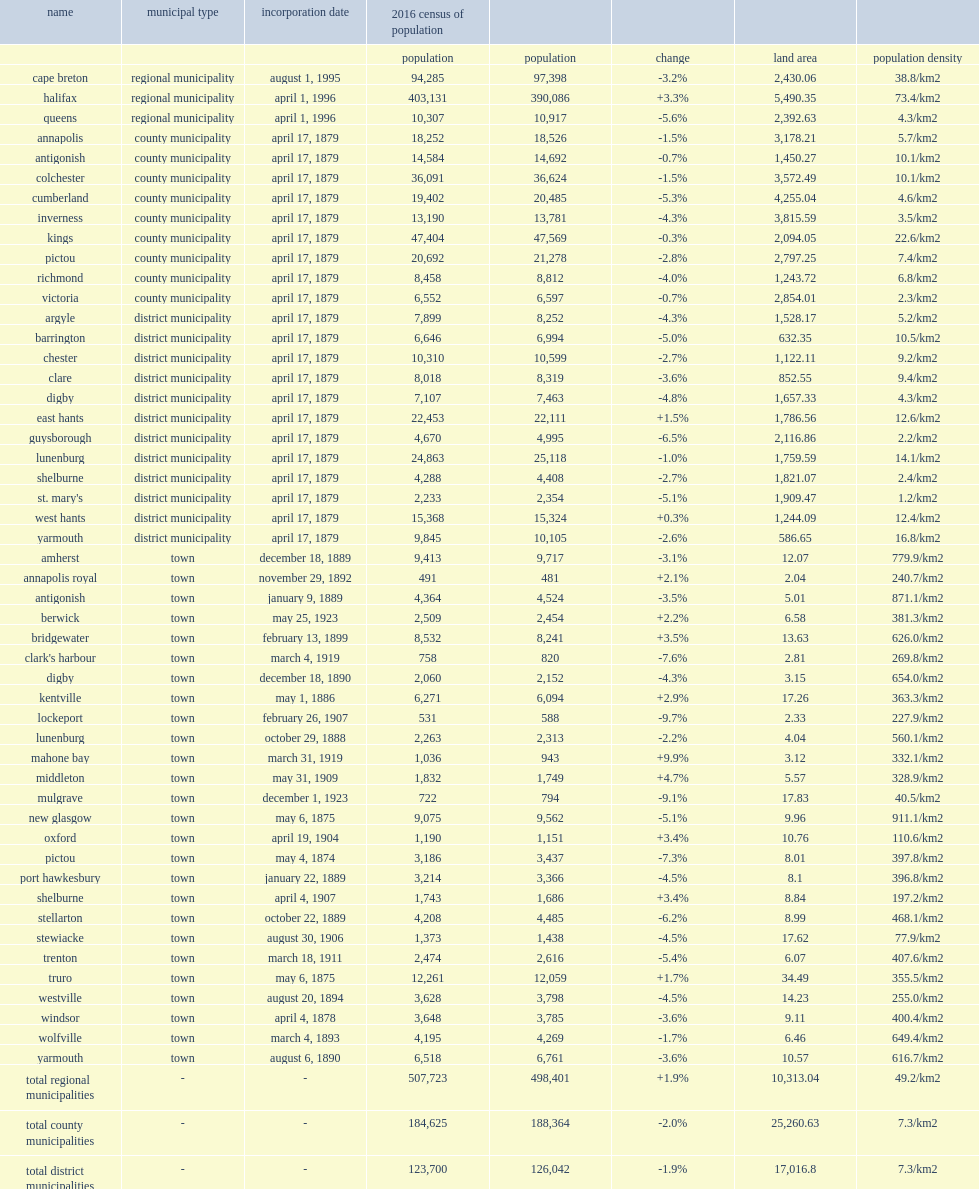How many residents do halifax have? 403131.0. 